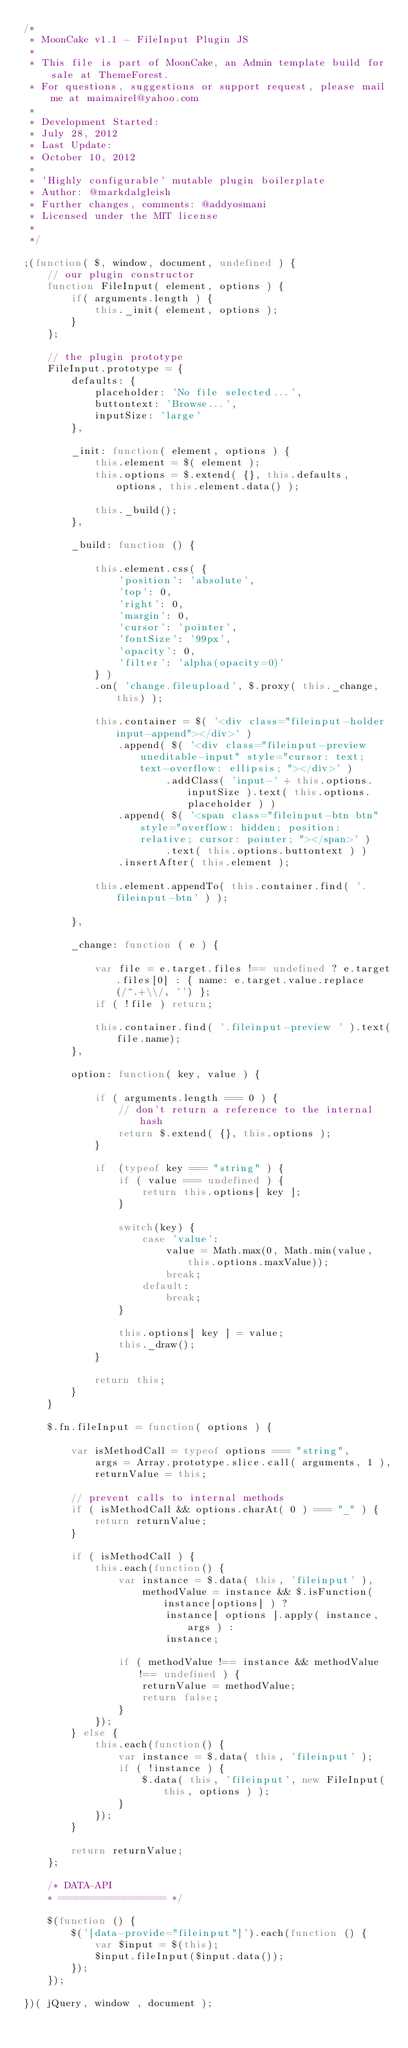<code> <loc_0><loc_0><loc_500><loc_500><_JavaScript_>/*
 * MoonCake v1.1 - FileInput Plugin JS
 *
 * This file is part of MoonCake, an Admin template build for sale at ThemeForest.
 * For questions, suggestions or support request, please mail me at maimairel@yahoo.com
 *
 * Development Started:
 * July 28, 2012
 * Last Update:
 * October 10, 2012
 *
 * 'Highly configurable' mutable plugin boilerplate
 * Author: @markdalgleish
 * Further changes, comments: @addyosmani
 * Licensed under the MIT license
 *
 */

;(function( $, window, document, undefined ) {
	// our plugin constructor
	function FileInput( element, options ) {
		if( arguments.length ) {
			this._init( element, options );
		}
    };
	
	// the plugin prototype
	FileInput.prototype = {
		defaults: {
			placeholder: 'No file selected...', 
			buttontext: 'Browse...', 
			inputSize: 'large'
		}, 

		_init: function( element, options ) {
			this.element = $( element );
			this.options = $.extend( {}, this.defaults, options, this.element.data() );

			this._build();
		}, 

		_build: function () {

			this.element.css( {
				'position': 'absolute', 
				'top': 0, 
				'right': 0, 
				'margin': 0, 
				'cursor': 'pointer', 
				'fontSize': '99px', 
				'opacity': 0, 
				'filter': 'alpha(opacity=0)'
			} )
			.on( 'change.fileupload', $.proxy( this._change, this) );

			this.container = $( '<div class="fileinput-holder input-append"></div>' )
				.append( $( '<div class="fileinput-preview uneditable-input" style="cursor: text; text-overflow: ellipsis; "></div>' )
						.addClass( 'input-' + this.options.inputSize ).text( this.options.placeholder ) )
				.append( $( '<span class="fileinput-btn btn" style="overflow: hidden; position: relative; cursor: pointer; "></span>' )
						.text( this.options.buttontext ) )
				.insertAfter( this.element );

			this.element.appendTo( this.container.find( '.fileinput-btn' ) );

		}, 

		_change: function ( e ) {
			
			var file = e.target.files !== undefined ? e.target.files[0] : { name: e.target.value.replace(/^.+\\/, '') };
			if ( !file ) return;
			
			this.container.find( '.fileinput-preview ' ).text(file.name);
		}, 

		option: function( key, value ) {
			
			if ( arguments.length === 0 ) {
				// don't return a reference to the internal hash
				return $.extend( {}, this.options );
			}

			if  (typeof key === "string" ) {
				if ( value === undefined ) {
					return this.options[ key ];
				}

				switch(key) {
					case 'value':
						value = Math.max(0, Math.min(value, this.options.maxValue));
						break;
					default:
						break;
				}

				this.options[ key ] = value;
				this._draw();
			}

			return this;
		}
	}

	$.fn.fileInput = function( options ) {

		var isMethodCall = typeof options === "string",
			args = Array.prototype.slice.call( arguments, 1 ),
			returnValue = this;

		// prevent calls to internal methods
		if ( isMethodCall && options.charAt( 0 ) === "_" ) {
			return returnValue;
		}

		if ( isMethodCall ) {
			this.each(function() {
				var instance = $.data( this, 'fileinput' ),
					methodValue = instance && $.isFunction( instance[options] ) ?
						instance[ options ].apply( instance, args ) :
						instance;

				if ( methodValue !== instance && methodValue !== undefined ) {
					returnValue = methodValue;
					return false;
				}
			});
		} else {
			this.each(function() {
				var instance = $.data( this, 'fileinput' );
				if ( !instance ) {
					$.data( this, 'fileinput', new FileInput( this, options ) );
				}
			});
		}

		return returnValue;
	};

	/* DATA-API
	* ================== */

	$(function () {
		$('[data-provide="fileinput"]').each(function () {
			var $input = $(this);
			$input.fileInput($input.data());
		});
	});

})( jQuery, window , document );
</code> 